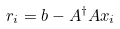Convert formula to latex. <formula><loc_0><loc_0><loc_500><loc_500>r _ { i } = b - A ^ { \dag } A x _ { i }</formula> 